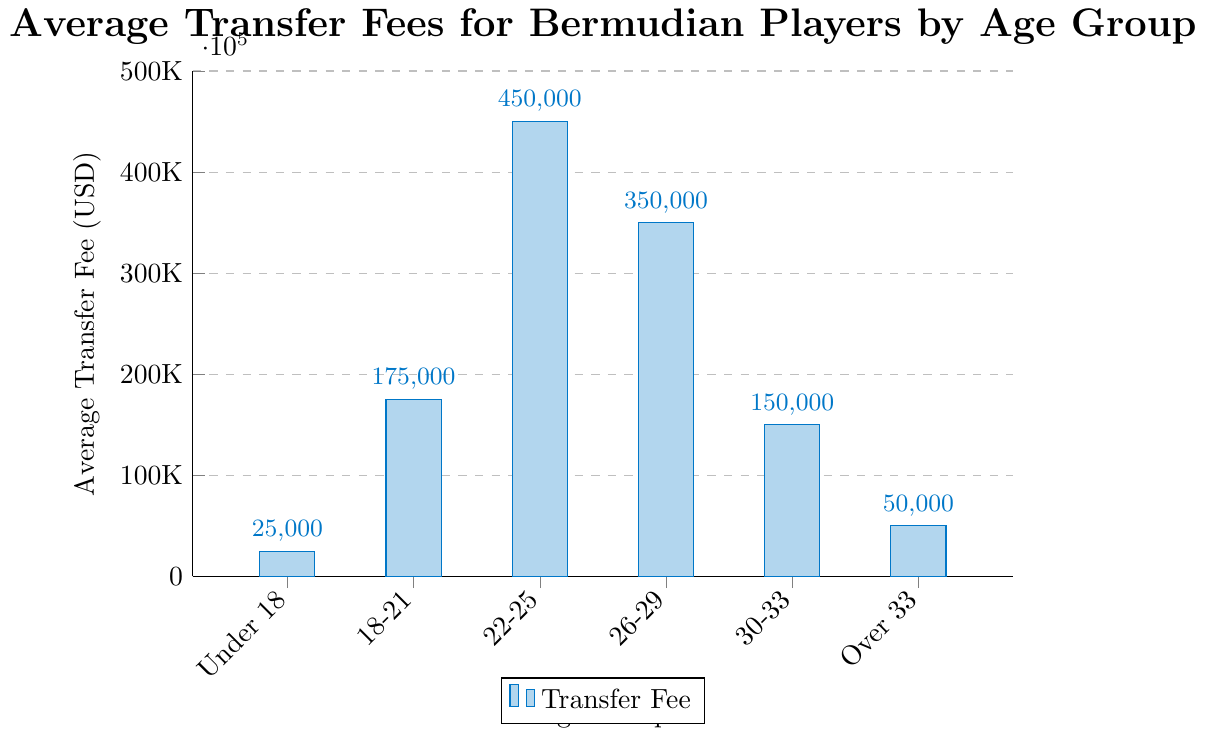What is the average transfer fee for players aged 22-25? Locate the bar representing the age group 22-25, which is labelled with the transfer fee of 450,000 USD.
Answer: 450,000 USD Which age group has the lowest average transfer fee? Compare the heights of all the bars and identify that the bar for the age group Under 18 with 25,000 USD is the shortest.
Answer: Under 18 What is the difference in average transfer fees between the 22-25 and 26-29 age groups? Locate the bars for 22-25 and 26-29, then subtract the value for 26-29 (350,000 USD) from the value for 22-25 (450,000 USD).
Answer: 100,000 USD What is the ratio of the average transfer fee for players aged 18-21 to those aged Over 33? Locate the bars for 18-21 (175,000 USD) and Over 33 (50,000 USD), then divide the value for 18-21 by the value for Over 33.
Answer: 3.5 In which age group does the average transfer fee increase most significantly compared to the previous age group? Compare the difference in values between consecutive bars. The largest increase is between the age groups 18-21 (175,000 USD) and 22-25 (450,000 USD), which is 275,000 USD.
Answer: 22-25 How many age groups have an average transfer fee of 200,000 USD or more? Count the bars with heights equal to or above 200,000 USD: 18-21 (175,000 USD), 22-25 (450,000 USD), and 26-29 (350,000 USD). Note that only 22-25 and 26-29 are 200,000 USD or more.
Answer: 2 What is the sum of average transfer fees for players under 18 and those over 33? Locate and sum the values for Under 18 (25,000 USD) and Over 33 (50,000 USD).
Answer: 75,000 USD What is the average transfer fee for players aged above 30? There are two bars for players aged above 30: 30-33 (150,000 USD) and Over 33 (50,000 USD). Sum these values and divide by 2: (150,000 + 50,000) / 2.
Answer: 100,000 USD 